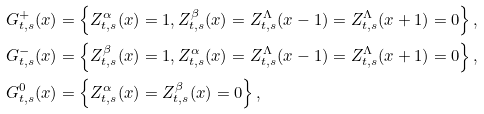<formula> <loc_0><loc_0><loc_500><loc_500>G ^ { + } _ { t , s } ( x ) & = \left \{ Z ^ { \alpha } _ { t , s } ( x ) = 1 , Z ^ { \beta } _ { t , s } ( x ) = Z ^ { \Lambda } _ { t , s } ( x - 1 ) = Z ^ { \Lambda } _ { t , s } ( x + 1 ) = 0 \right \} , \\ G ^ { - } _ { t , s } ( x ) & = \left \{ Z ^ { \beta } _ { t , s } ( x ) = 1 , Z ^ { \alpha } _ { t , s } ( x ) = Z ^ { \Lambda } _ { t , s } ( x - 1 ) = Z ^ { \Lambda } _ { t , s } ( x + 1 ) = 0 \right \} , \\ G ^ { 0 } _ { t , s } ( x ) & = \left \{ Z ^ { \alpha } _ { t , s } ( x ) = Z ^ { \beta } _ { t , s } ( x ) = 0 \right \} ,</formula> 